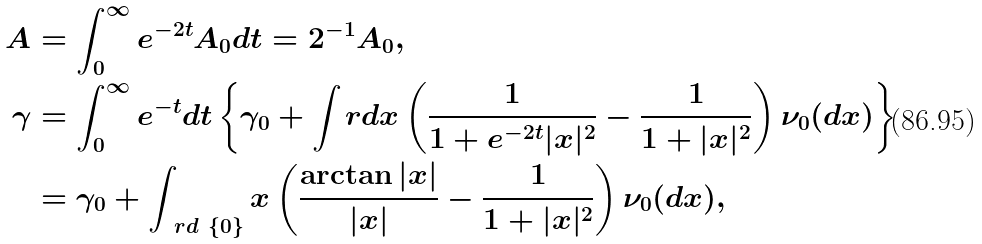<formula> <loc_0><loc_0><loc_500><loc_500>A & = \int _ { 0 } ^ { \infty } e ^ { - 2 t } A _ { 0 } d t = 2 ^ { - 1 } A _ { 0 } , \\ \gamma & = \int _ { 0 } ^ { \infty } e ^ { - t } d t \left \{ \gamma _ { 0 } + \int _ { \ } r d x \left ( \frac { 1 } { 1 + e ^ { - 2 t } | x | ^ { 2 } } - \frac { 1 } { 1 + | x | ^ { 2 } } \right ) \nu _ { 0 } ( d x ) \right \} \\ & = \gamma _ { 0 } + \int _ { \ r d \ \{ 0 \} } x \left ( \frac { \arctan | x | } { | x | } - \frac { 1 } { 1 + | x | ^ { 2 } } \right ) \nu _ { 0 } ( d x ) ,</formula> 